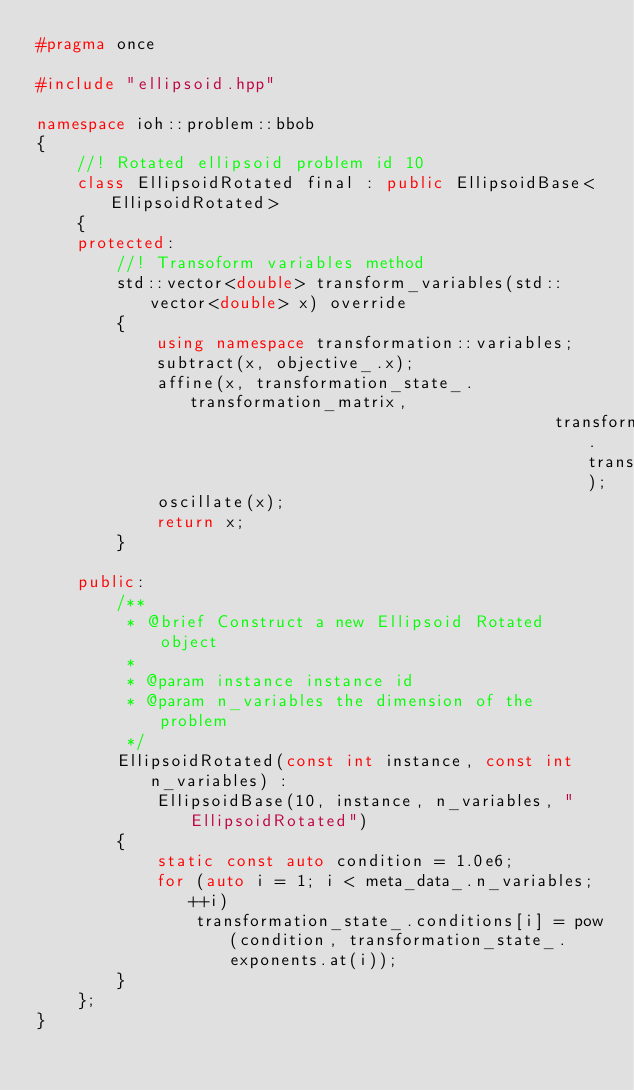<code> <loc_0><loc_0><loc_500><loc_500><_C++_>#pragma once

#include "ellipsoid.hpp"

namespace ioh::problem::bbob
{
    //! Rotated ellipsoid problem id 10
    class EllipsoidRotated final : public EllipsoidBase<EllipsoidRotated>
    {
    protected:
        //! Transoform variables method
        std::vector<double> transform_variables(std::vector<double> x) override
        {
            using namespace transformation::variables;
            subtract(x, objective_.x);
            affine(x, transformation_state_.transformation_matrix,
                                                    transformation_state_.transformation_base);
            oscillate(x);
            return x;
        }

    public:
        /**
         * @brief Construct a new Ellipsoid Rotated object
         * 
         * @param instance instance id
         * @param n_variables the dimension of the problem
         */
        EllipsoidRotated(const int instance, const int n_variables) :
            EllipsoidBase(10, instance, n_variables, "EllipsoidRotated")
        {
            static const auto condition = 1.0e6;
            for (auto i = 1; i < meta_data_.n_variables; ++i)
                transformation_state_.conditions[i] = pow(condition, transformation_state_.exponents.at(i));
        }
    };
}
</code> 